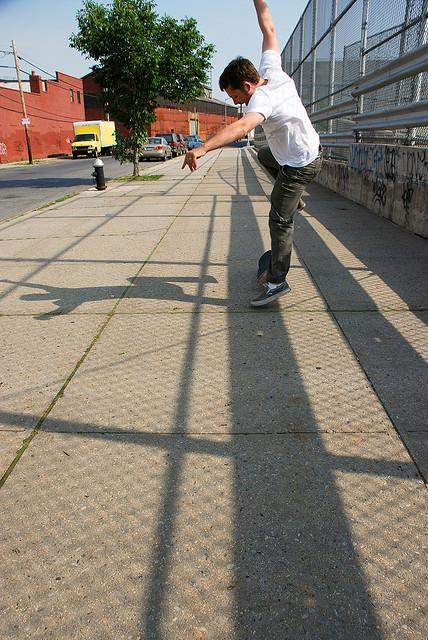The shadow of what is visible? Please explain your reasoning. skateboarder. The shadow of the person on the skateboarding can be seen on the ground. 